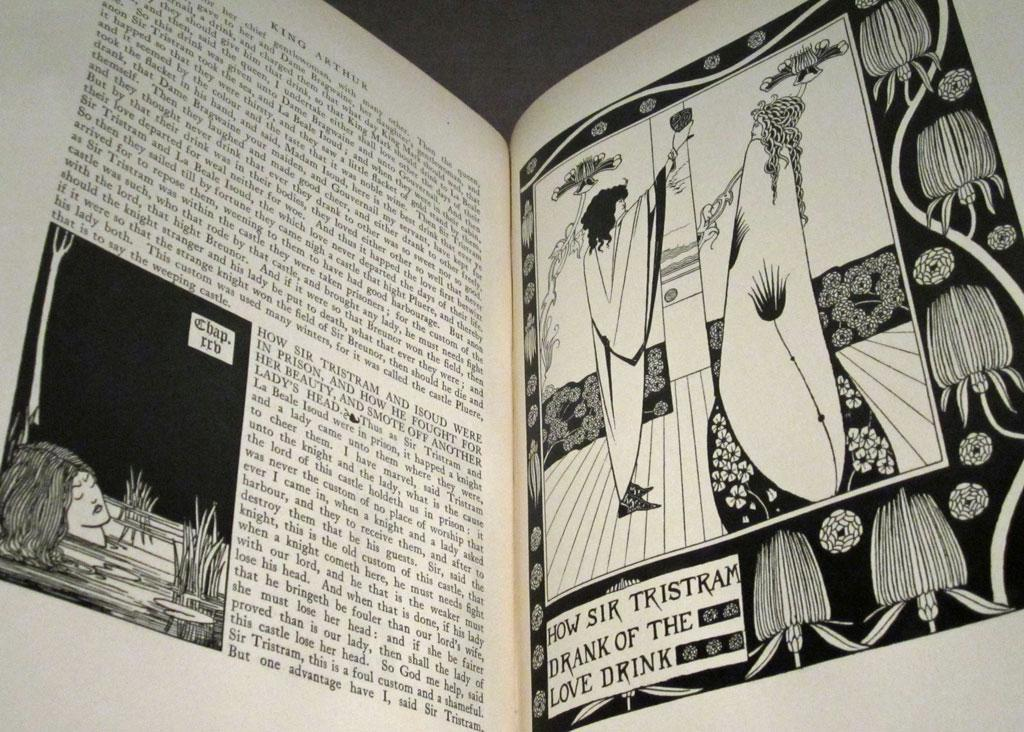<image>
Relay a brief, clear account of the picture shown. A caption under a black and white drawing says "how sir Tristram drank of the love drink". 